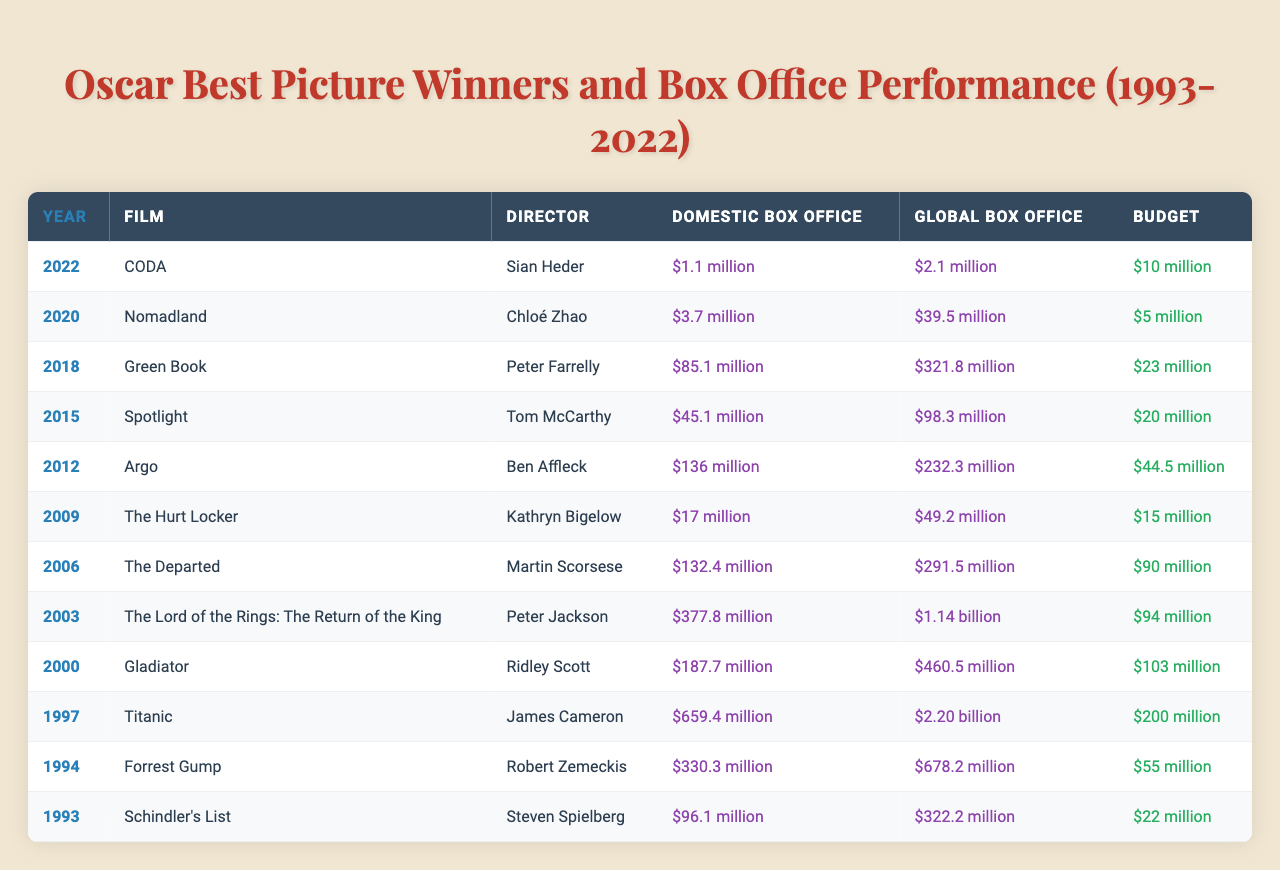What film won the Oscar for Best Picture in 2018? According to the table, the film listed in 2018 is "Green Book" as the Best Picture winner.
Answer: Green Book What is the domestic box office gross for "Titanic"? The table shows that "Titanic," which won in 1997, had a domestic box office of $659.4 million.
Answer: $659.4 million Which film had the highest global box office gross among the winners? By comparing the global box office figures in the table, "Titanic" leads with $2.20 billion.
Answer: Titanic What is the difference between the global box office of "Gladiator" and its budget? The global box office for "Gladiator" is $460.5 million, and the budget is $103 million, making the difference $460.5 million - $103 million = $357.5 million.
Answer: $357.5 million How many Best Picture winners had a domestic box office gross of over $100 million? Reviewing the data, films with domestic box office over $100 million include "Argo," "The Departed," "Titanic," and "Gladiator," totaling four winners.
Answer: 4 What is the average budget of all the films listed in the table? To find the average budget, sum the budgets: $10 million + $5 million + $23 million + $20 million + $44.5 million + $15 million + $90 million + $94 million + $103 million + $200 million + $55 million + $22 million = $ 1282.5 million; then divide by 12 (the number of films), resulting in $106.875 million.
Answer: $106.88 million In which year did "Nomadland" win, and what was its global box office? The table indicates that "Nomadland" won in 2020, with a global box office of $39.5 million.
Answer: 2020, $39.5 million Did any films have a global box office gross less than their budget? Looking at the table, "CODA" had a global box office of $2.1 million compared to its budget of $10 million, indicating it fell short.
Answer: Yes Which director has the highest-grossing film among the winners listed? "Titanic," directed by James Cameron, shows the highest gross at $2.20 billion globally, making him the highest-grossing director on the list.
Answer: James Cameron What percentage of the global box office did "The Hurt Locker" achieve relative to its budget? "The Hurt Locker" had a global box office of $49.2 million and a budget of $15 million. The percentage is ($49.2 million / $15 million) * 100 = 328%.
Answer: 328% Which film has the lowest domestic box office and what is the amount? According to the table, "CODA" has the lowest domestic box office gross listed at $1.1 million.
Answer: $1.1 million 